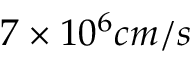Convert formula to latex. <formula><loc_0><loc_0><loc_500><loc_500>7 \times 1 0 ^ { 6 } c m / s</formula> 